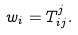<formula> <loc_0><loc_0><loc_500><loc_500>w _ { i } = T _ { i j } ^ { j } .</formula> 